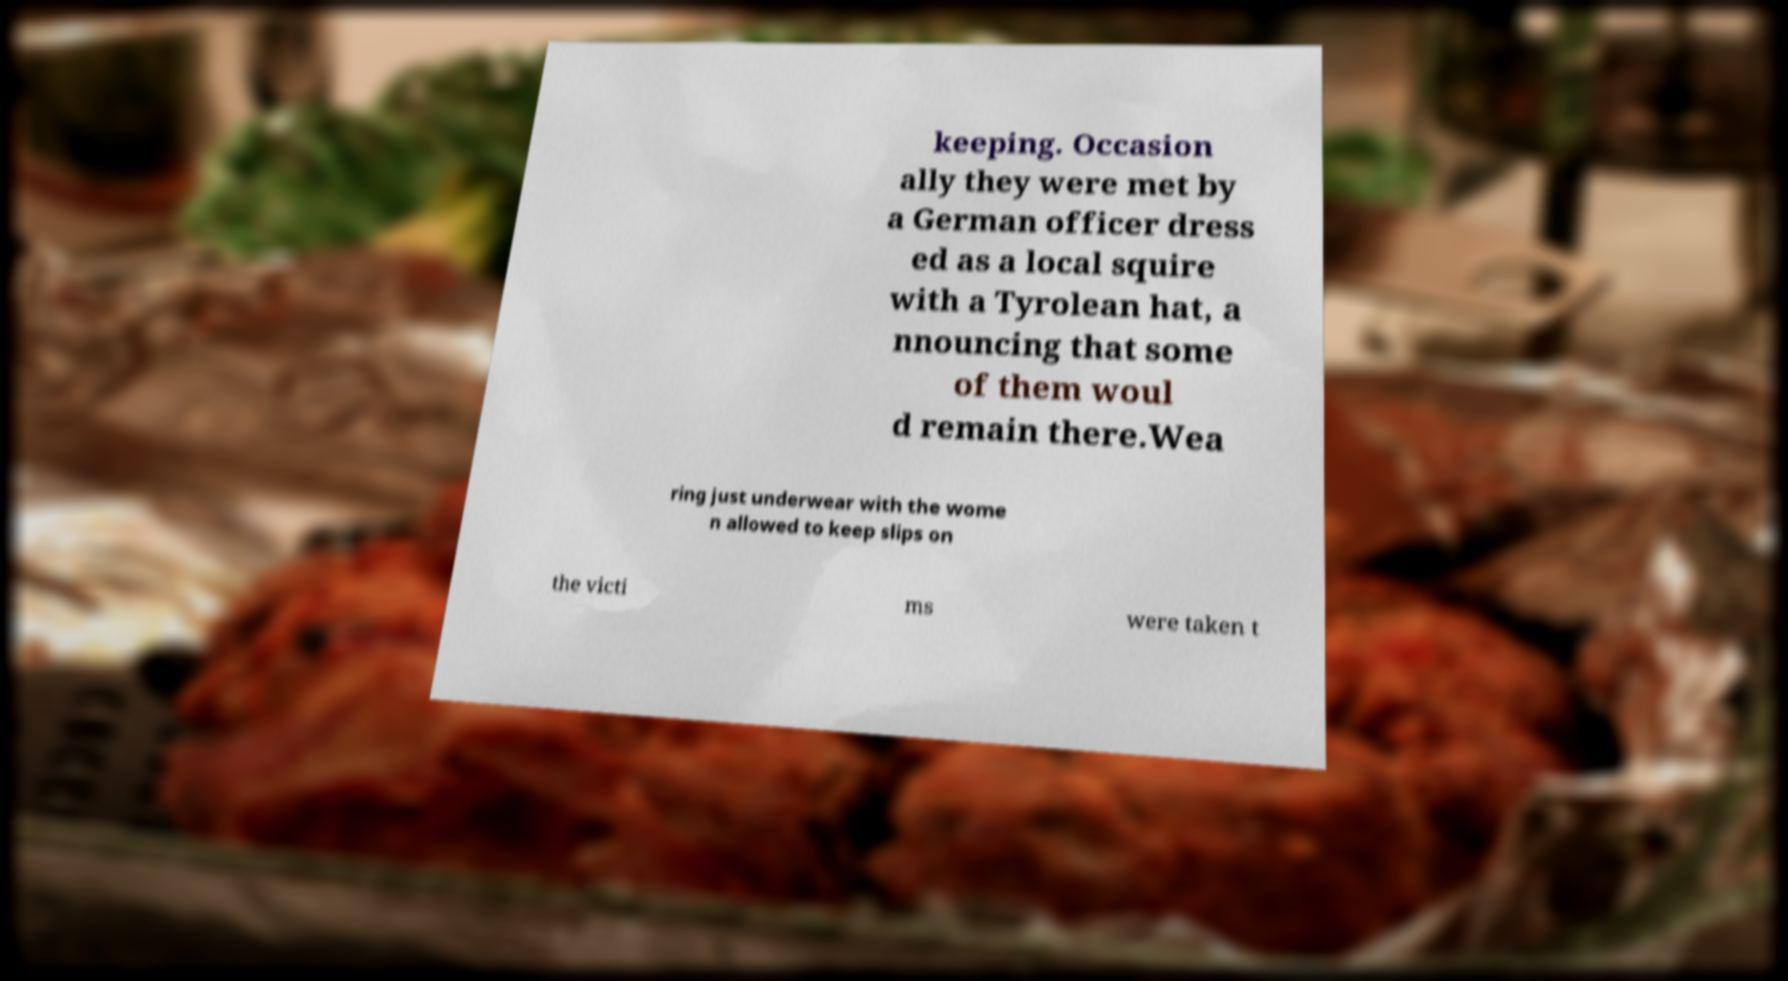What messages or text are displayed in this image? I need them in a readable, typed format. keeping. Occasion ally they were met by a German officer dress ed as a local squire with a Tyrolean hat, a nnouncing that some of them woul d remain there.Wea ring just underwear with the wome n allowed to keep slips on the victi ms were taken t 